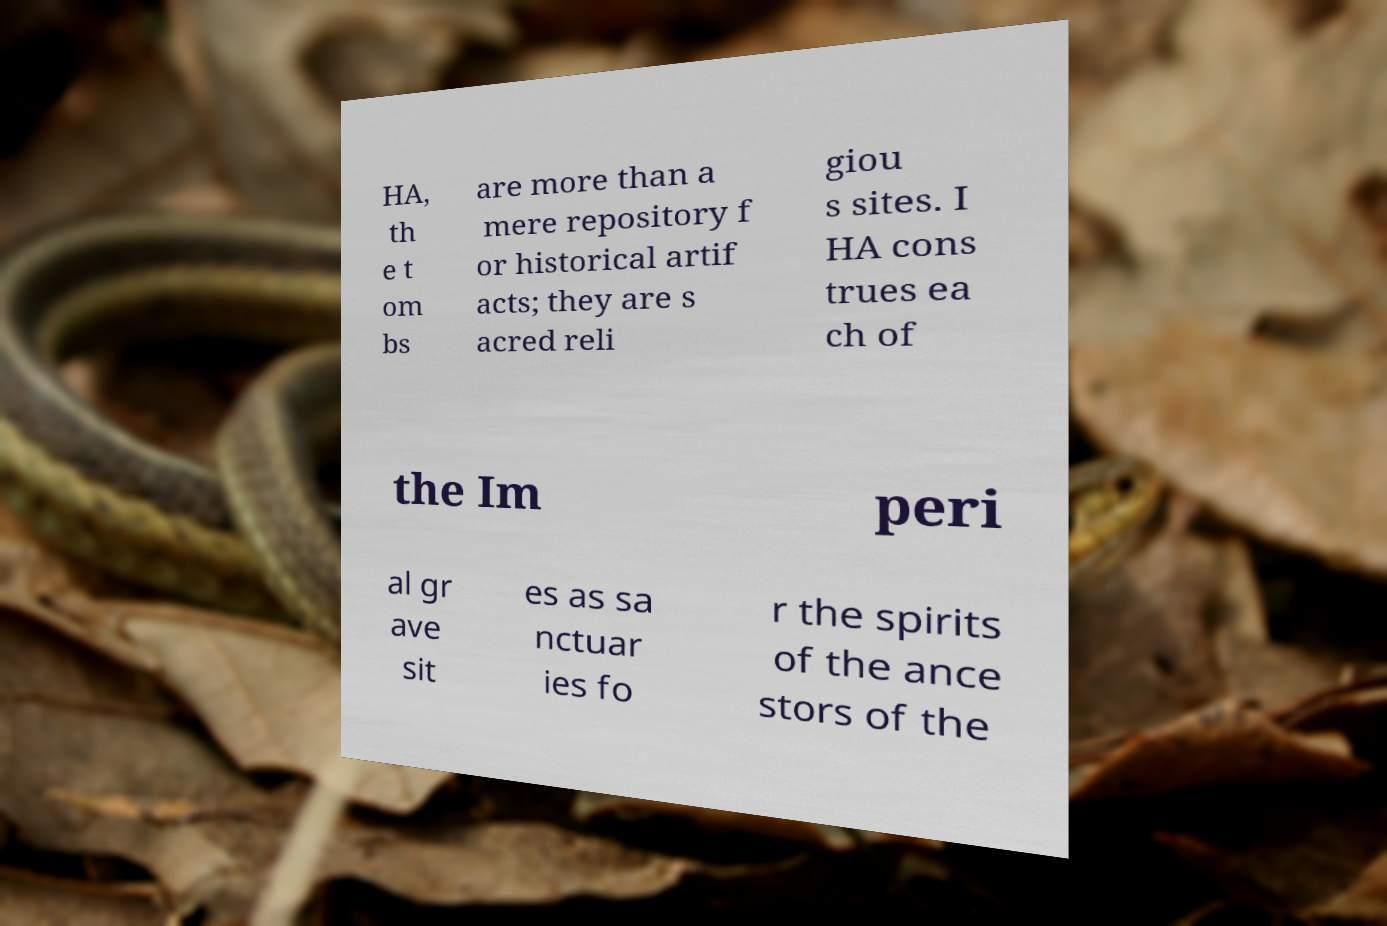I need the written content from this picture converted into text. Can you do that? HA, th e t om bs are more than a mere repository f or historical artif acts; they are s acred reli giou s sites. I HA cons trues ea ch of the Im peri al gr ave sit es as sa nctuar ies fo r the spirits of the ance stors of the 